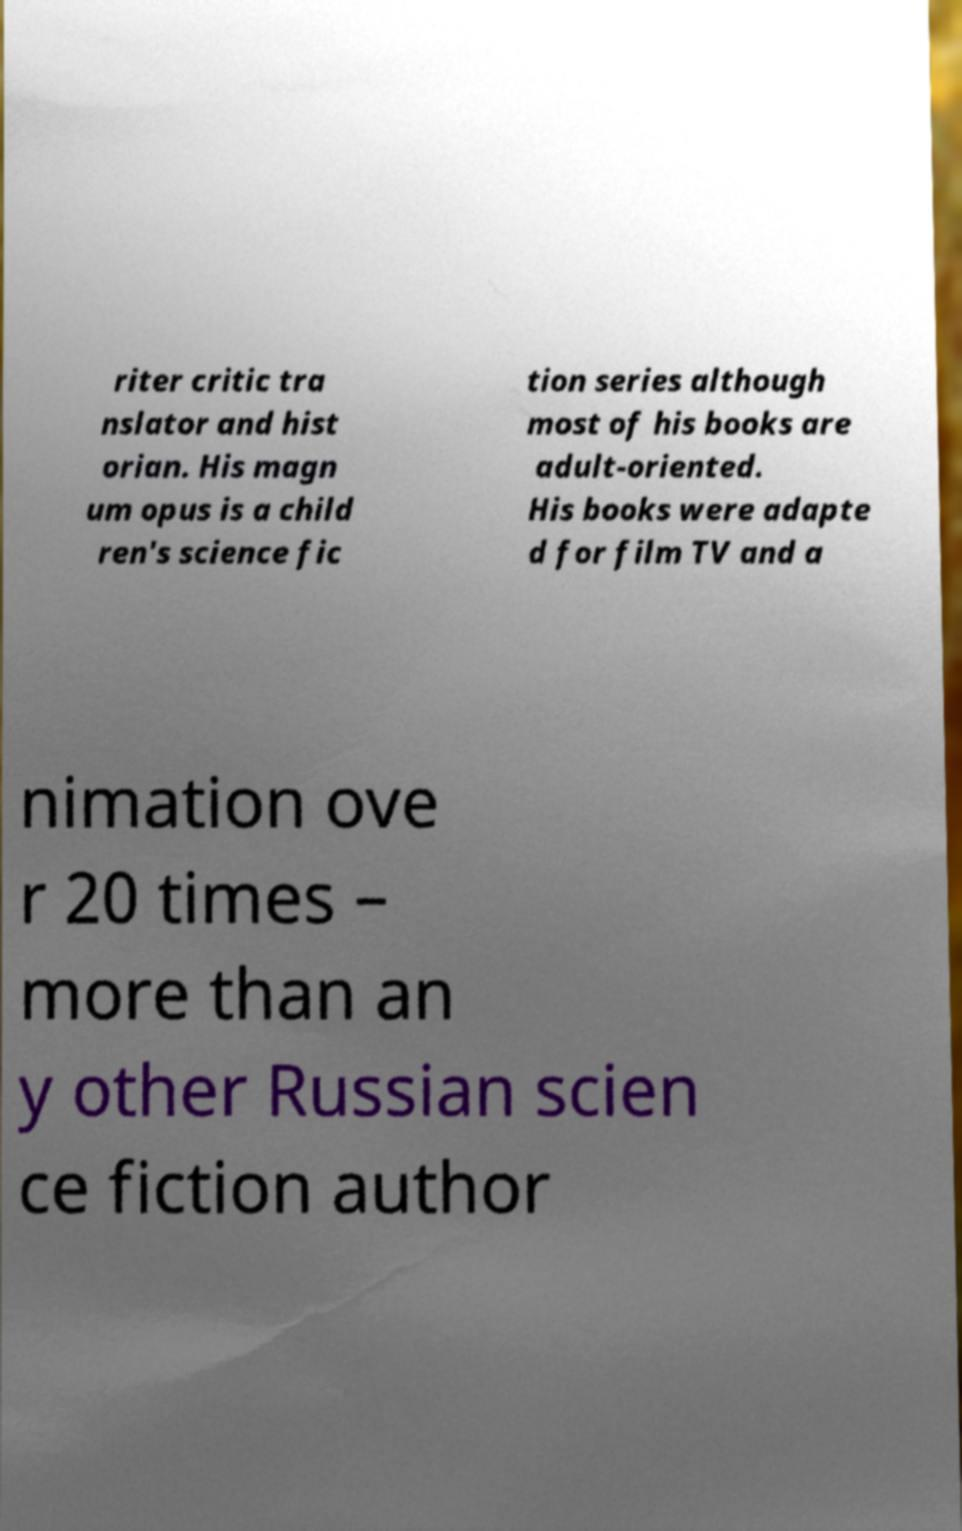Please read and relay the text visible in this image. What does it say? riter critic tra nslator and hist orian. His magn um opus is a child ren's science fic tion series although most of his books are adult-oriented. His books were adapte d for film TV and a nimation ove r 20 times – more than an y other Russian scien ce fiction author 